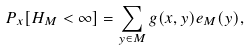<formula> <loc_0><loc_0><loc_500><loc_500>P _ { x } [ H _ { M } < \infty ] = \sum _ { y \in M } g ( x , y ) e _ { M } ( y ) ,</formula> 